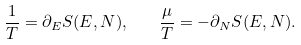<formula> <loc_0><loc_0><loc_500><loc_500>\frac { 1 } { T } = \partial _ { E } S ( E , N ) , \quad \frac { \mu } { T } = - \partial _ { N } S ( E , N ) .</formula> 